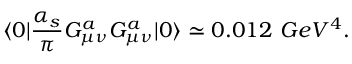<formula> <loc_0><loc_0><loc_500><loc_500>\langle { 0 } | { \frac { \alpha _ { s } } { \pi } } G _ { \mu \nu } ^ { a } G _ { \mu \nu } ^ { a } | { 0 } \rangle \simeq 0 . 0 1 2 \ G e V ^ { 4 } .</formula> 